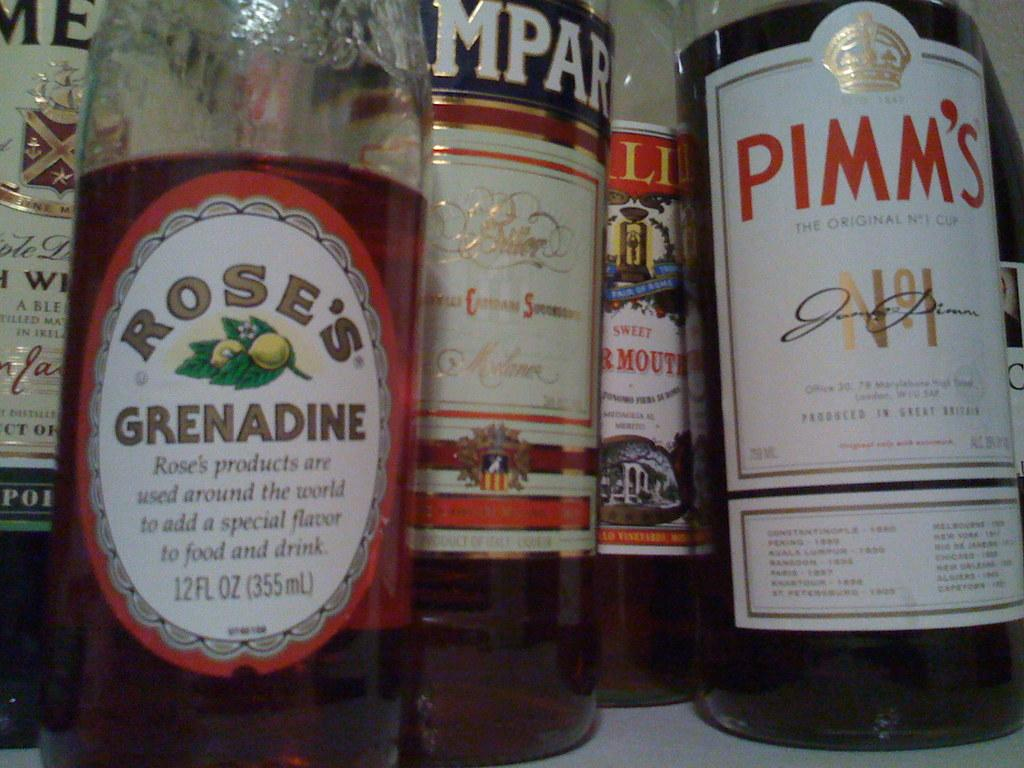<image>
Share a concise interpretation of the image provided. A shelf full of different alcohol varieties includes a bottle of Rose's Grenadine. 